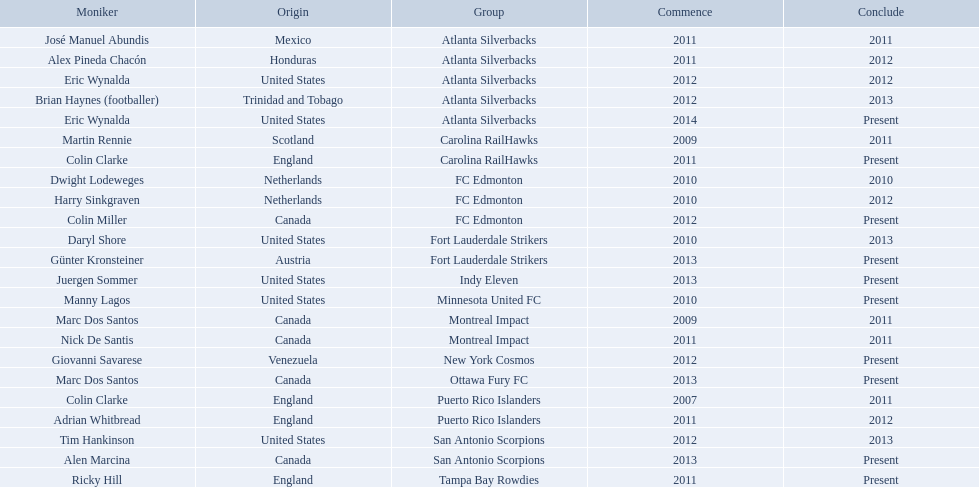What year did marc dos santos start as coach? 2009. Which other starting years correspond with this year? 2009. Who was the other coach with this starting year Martin Rennie. What were all the coaches who were coaching in 2010? Martin Rennie, Dwight Lodeweges, Harry Sinkgraven, Daryl Shore, Manny Lagos, Marc Dos Santos, Colin Clarke. Which of the 2010 coaches were not born in north america? Martin Rennie, Dwight Lodeweges, Harry Sinkgraven, Colin Clarke. Which coaches that were coaching in 2010 and were not from north america did not coach for fc edmonton? Martin Rennie, Colin Clarke. What coach did not coach for fc edmonton in 2010 and was not north american nationality had the shortened career as a coach? Martin Rennie. 